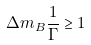Convert formula to latex. <formula><loc_0><loc_0><loc_500><loc_500>\Delta m _ { B } \frac { 1 } { \Gamma } \geq 1</formula> 